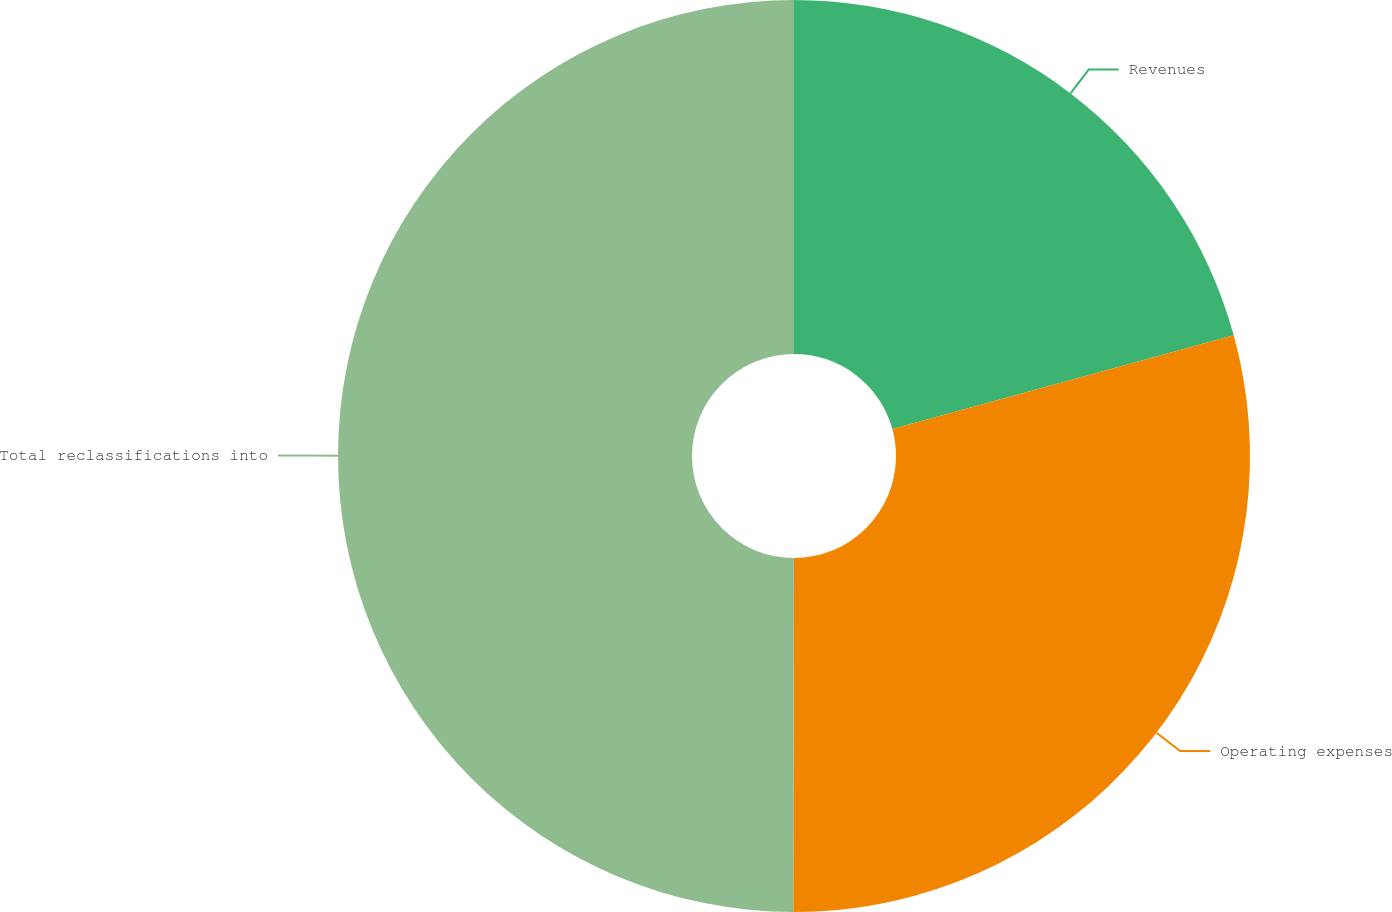Convert chart to OTSL. <chart><loc_0><loc_0><loc_500><loc_500><pie_chart><fcel>Revenues<fcel>Operating expenses<fcel>Total reclassifications into<nl><fcel>20.74%<fcel>29.29%<fcel>49.98%<nl></chart> 